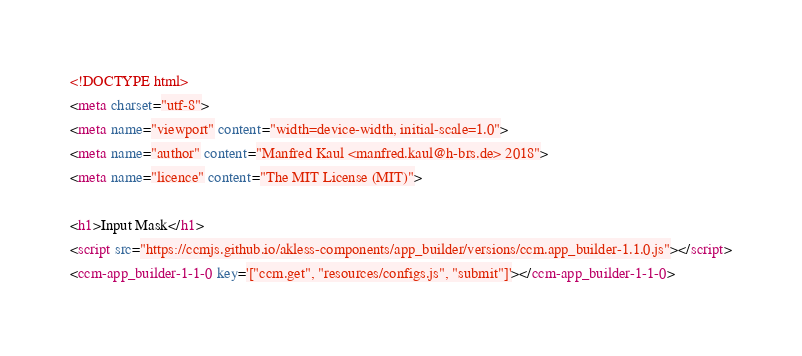Convert code to text. <code><loc_0><loc_0><loc_500><loc_500><_HTML_><!DOCTYPE html>
<meta charset="utf-8">
<meta name="viewport" content="width=device-width, initial-scale=1.0">
<meta name="author" content="Manfred Kaul <manfred.kaul@h-brs.de> 2018">
<meta name="licence" content="The MIT License (MIT)">

<h1>Input Mask</h1>
<script src="https://ccmjs.github.io/akless-components/app_builder/versions/ccm.app_builder-1.1.0.js"></script>
<ccm-app_builder-1-1-0 key='["ccm.get", "resources/configs.js", "submit"]'></ccm-app_builder-1-1-0></code> 